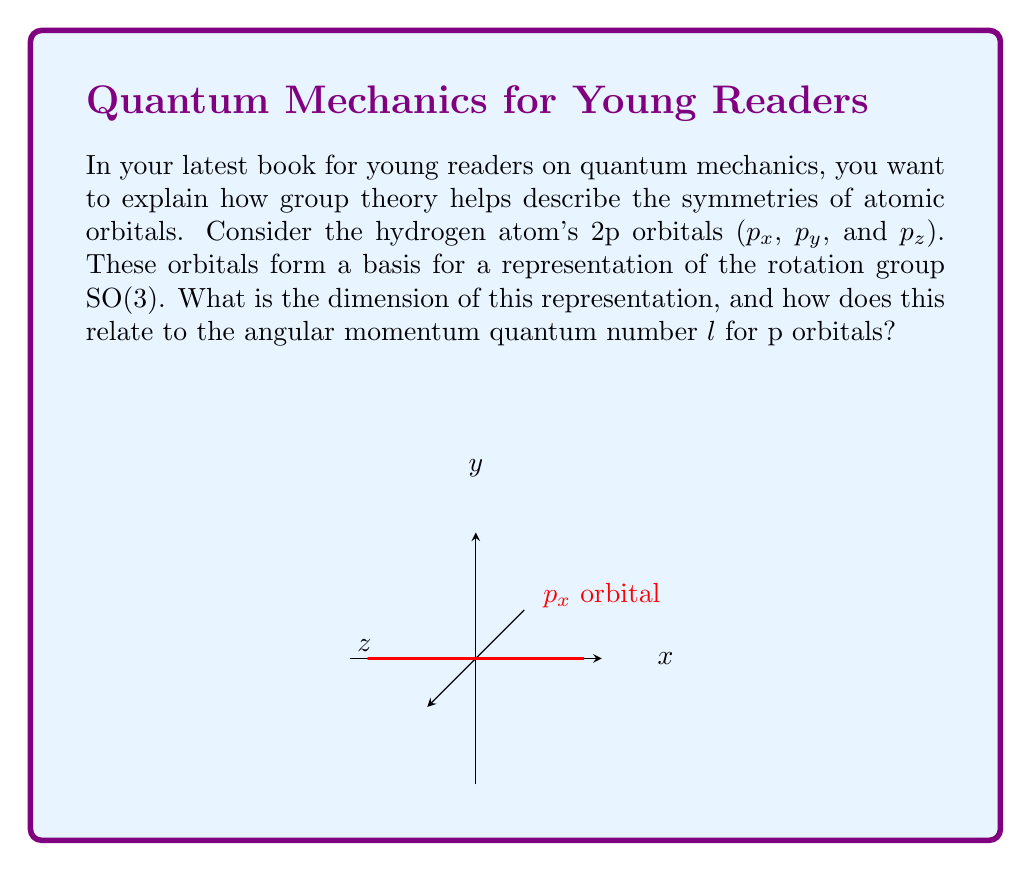Help me with this question. Let's approach this step-by-step:

1) In quantum mechanics, the p orbitals ($p_x$, $p_y$, and $p_z$) correspond to the angular momentum quantum number $l = 1$.

2) For a given $l$, there are $2l + 1$ possible values for the magnetic quantum number $m_l$, ranging from $-l$ to $+l$ in integer steps.

3) For p orbitals ($l = 1$), the possible $m_l$ values are:
   $$m_l = -1, 0, +1$$

4) These three values correspond to the three p orbitals:
   - $p_x$ and $p_y$ are linear combinations of $m_l = +1$ and $m_l = -1$
   - $p_z$ corresponds to $m_l = 0$

5) In group theory, these three orbitals form a basis for a representation of the rotation group SO(3). The dimension of this representation is equal to the number of basis functions, which is 3.

6) This dimension is directly related to the angular momentum quantum number $l$ by the formula:
   $$\text{dimension} = 2l + 1$$

7) Indeed, for p orbitals ($l = 1$):
   $$2l + 1 = 2(1) + 1 = 3$$

This demonstrates how the group theoretical concept of representation dimension is directly linked to the quantum mechanical concept of angular momentum.
Answer: The dimension is 3, equal to $2l + 1$ for $l = 1$ (p orbitals). 